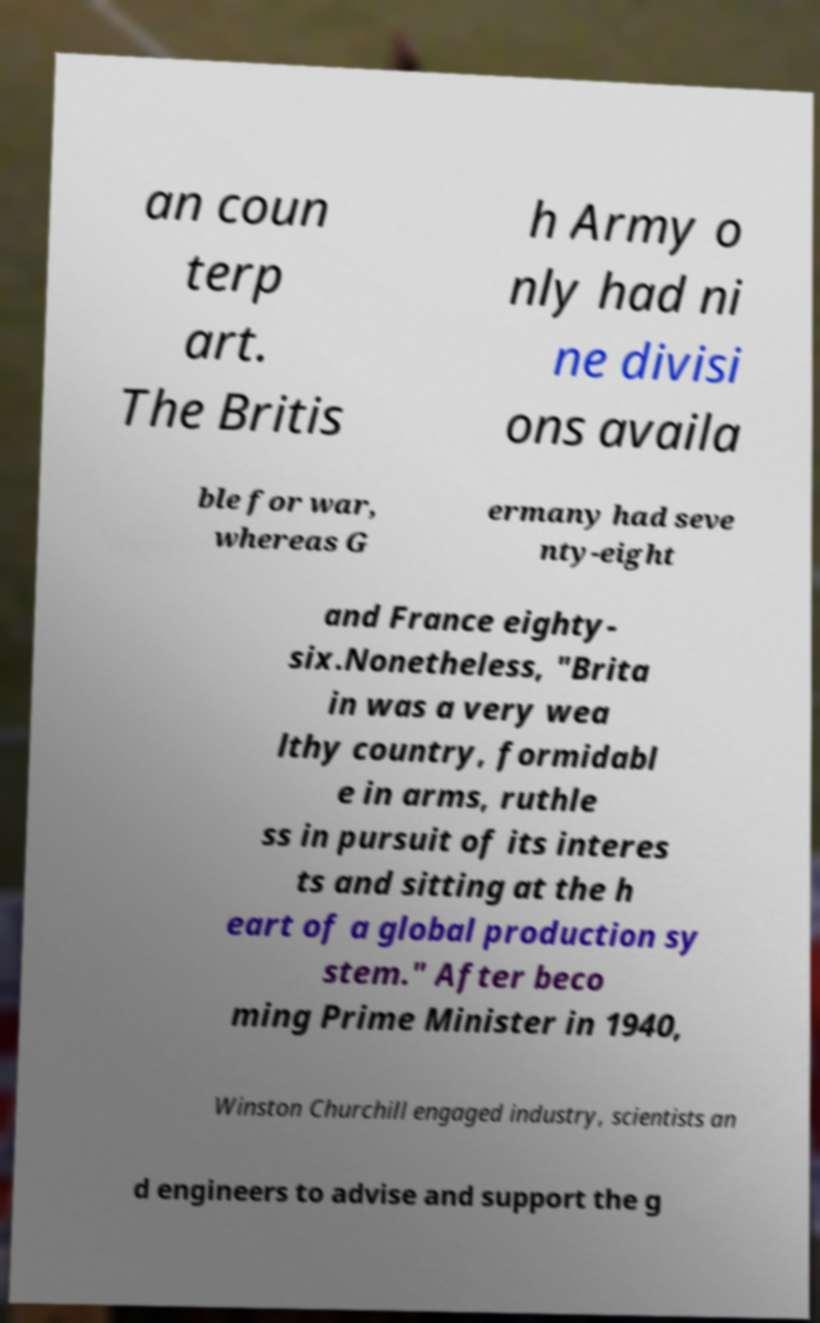Please identify and transcribe the text found in this image. an coun terp art. The Britis h Army o nly had ni ne divisi ons availa ble for war, whereas G ermany had seve nty-eight and France eighty- six.Nonetheless, "Brita in was a very wea lthy country, formidabl e in arms, ruthle ss in pursuit of its interes ts and sitting at the h eart of a global production sy stem." After beco ming Prime Minister in 1940, Winston Churchill engaged industry, scientists an d engineers to advise and support the g 